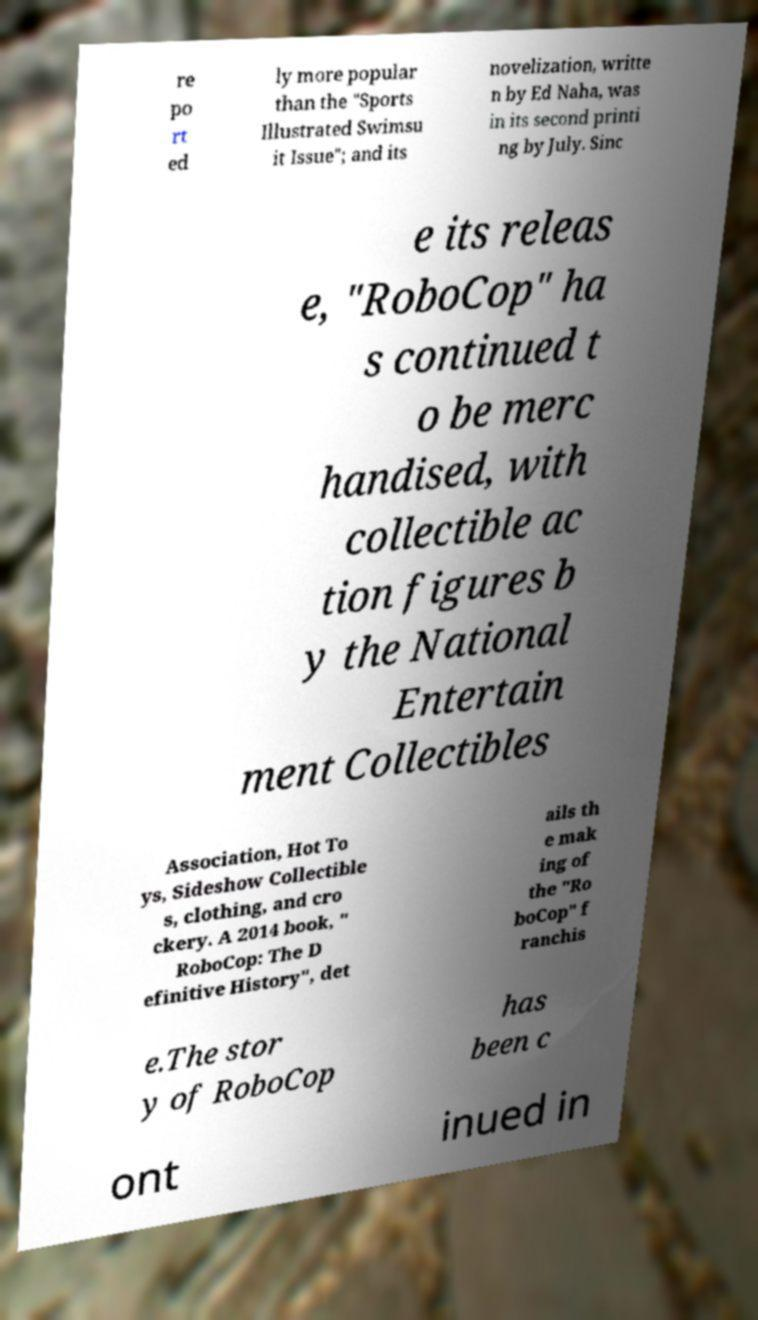There's text embedded in this image that I need extracted. Can you transcribe it verbatim? re po rt ed ly more popular than the "Sports Illustrated Swimsu it Issue"; and its novelization, writte n by Ed Naha, was in its second printi ng by July. Sinc e its releas e, "RoboCop" ha s continued t o be merc handised, with collectible ac tion figures b y the National Entertain ment Collectibles Association, Hot To ys, Sideshow Collectible s, clothing, and cro ckery. A 2014 book, " RoboCop: The D efinitive History", det ails th e mak ing of the "Ro boCop" f ranchis e.The stor y of RoboCop has been c ont inued in 